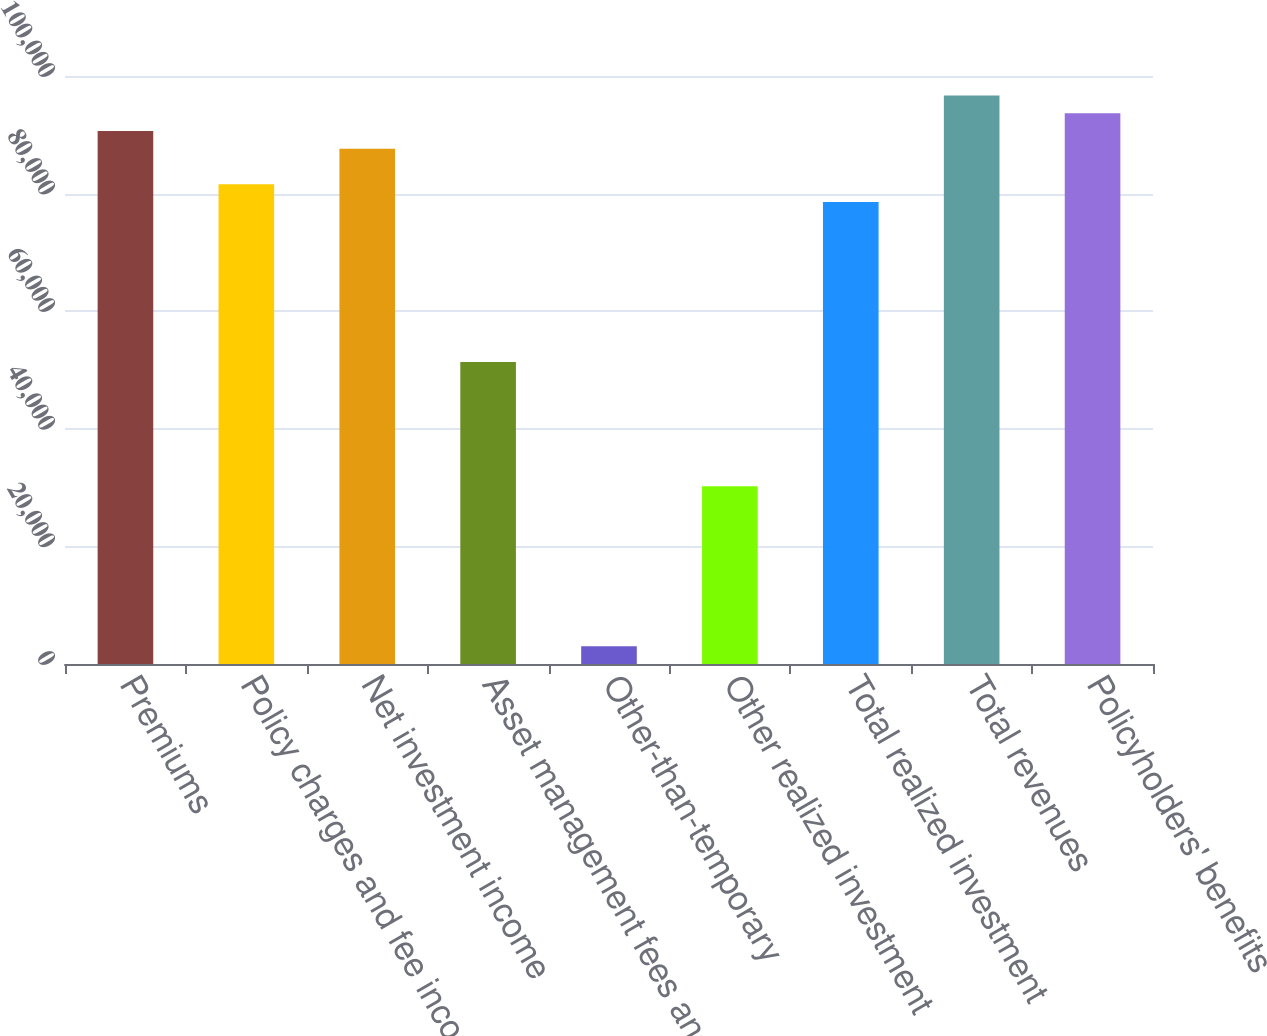Convert chart to OTSL. <chart><loc_0><loc_0><loc_500><loc_500><bar_chart><fcel>Premiums<fcel>Policy charges and fee income<fcel>Net investment income<fcel>Asset management fees and<fcel>Other-than-temporary<fcel>Other realized investment<fcel>Total realized investment<fcel>Total revenues<fcel>Policyholders' benefits<nl><fcel>90646.8<fcel>81582.2<fcel>87625.2<fcel>51366.8<fcel>3022.12<fcel>30216<fcel>78560.6<fcel>96689.9<fcel>93668.3<nl></chart> 